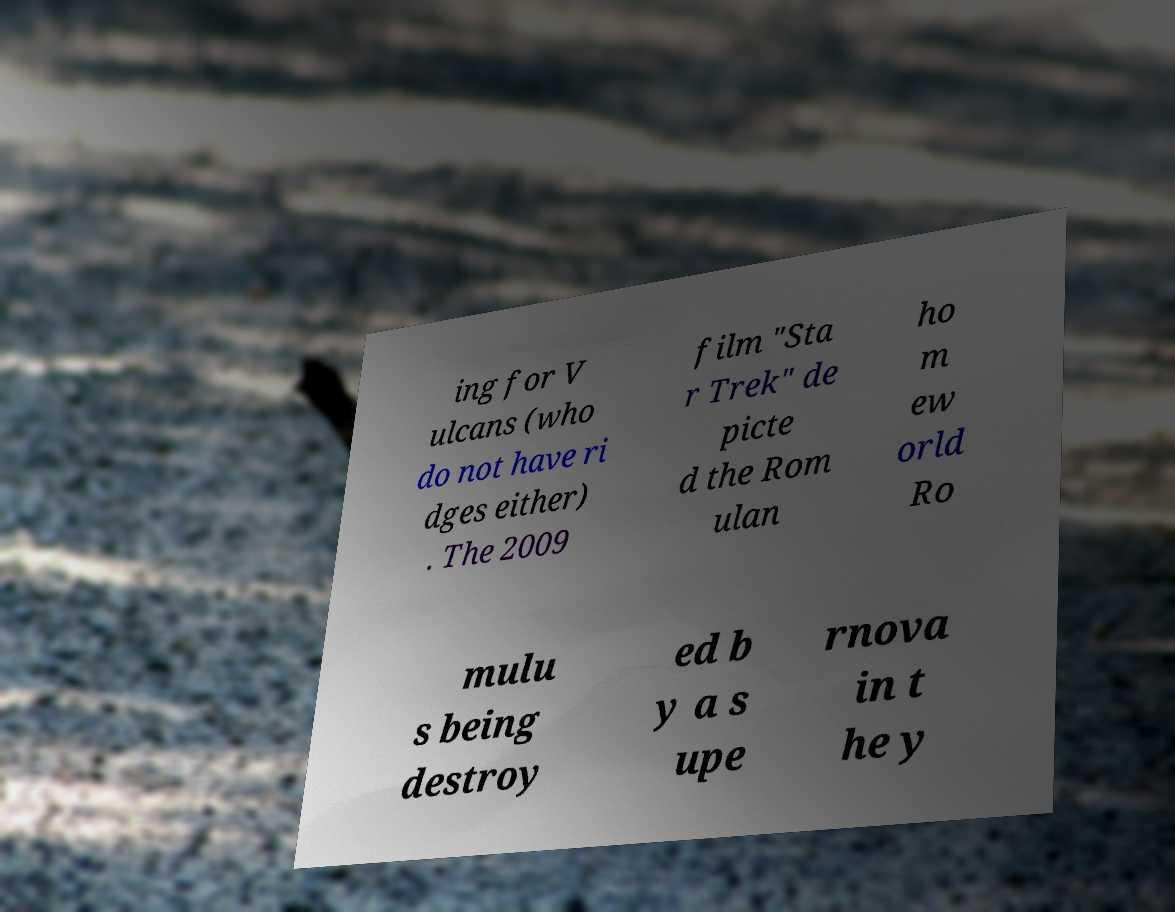For documentation purposes, I need the text within this image transcribed. Could you provide that? ing for V ulcans (who do not have ri dges either) . The 2009 film "Sta r Trek" de picte d the Rom ulan ho m ew orld Ro mulu s being destroy ed b y a s upe rnova in t he y 